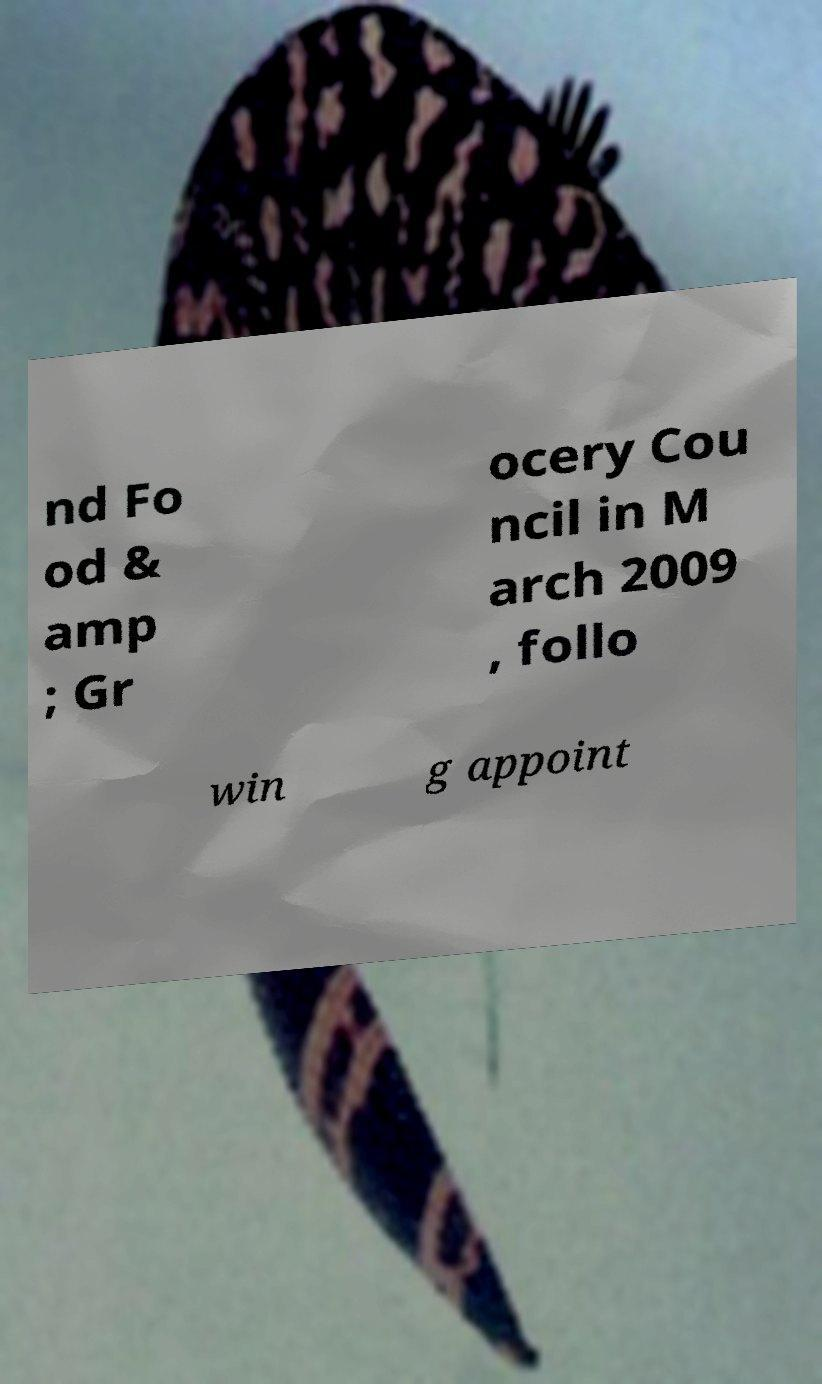Can you accurately transcribe the text from the provided image for me? nd Fo od & amp ; Gr ocery Cou ncil in M arch 2009 , follo win g appoint 